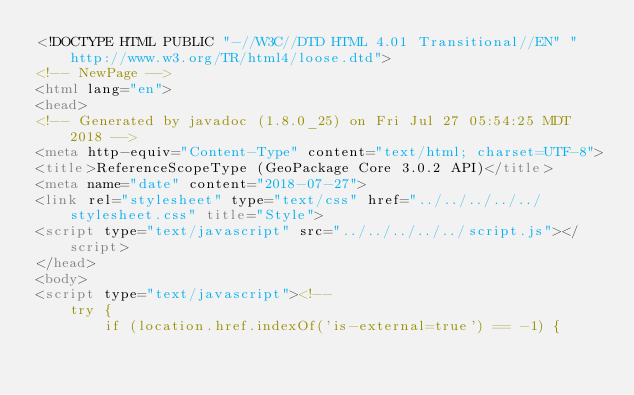<code> <loc_0><loc_0><loc_500><loc_500><_HTML_><!DOCTYPE HTML PUBLIC "-//W3C//DTD HTML 4.01 Transitional//EN" "http://www.w3.org/TR/html4/loose.dtd">
<!-- NewPage -->
<html lang="en">
<head>
<!-- Generated by javadoc (1.8.0_25) on Fri Jul 27 05:54:25 MDT 2018 -->
<meta http-equiv="Content-Type" content="text/html; charset=UTF-8">
<title>ReferenceScopeType (GeoPackage Core 3.0.2 API)</title>
<meta name="date" content="2018-07-27">
<link rel="stylesheet" type="text/css" href="../../../../../stylesheet.css" title="Style">
<script type="text/javascript" src="../../../../../script.js"></script>
</head>
<body>
<script type="text/javascript"><!--
    try {
        if (location.href.indexOf('is-external=true') == -1) {</code> 